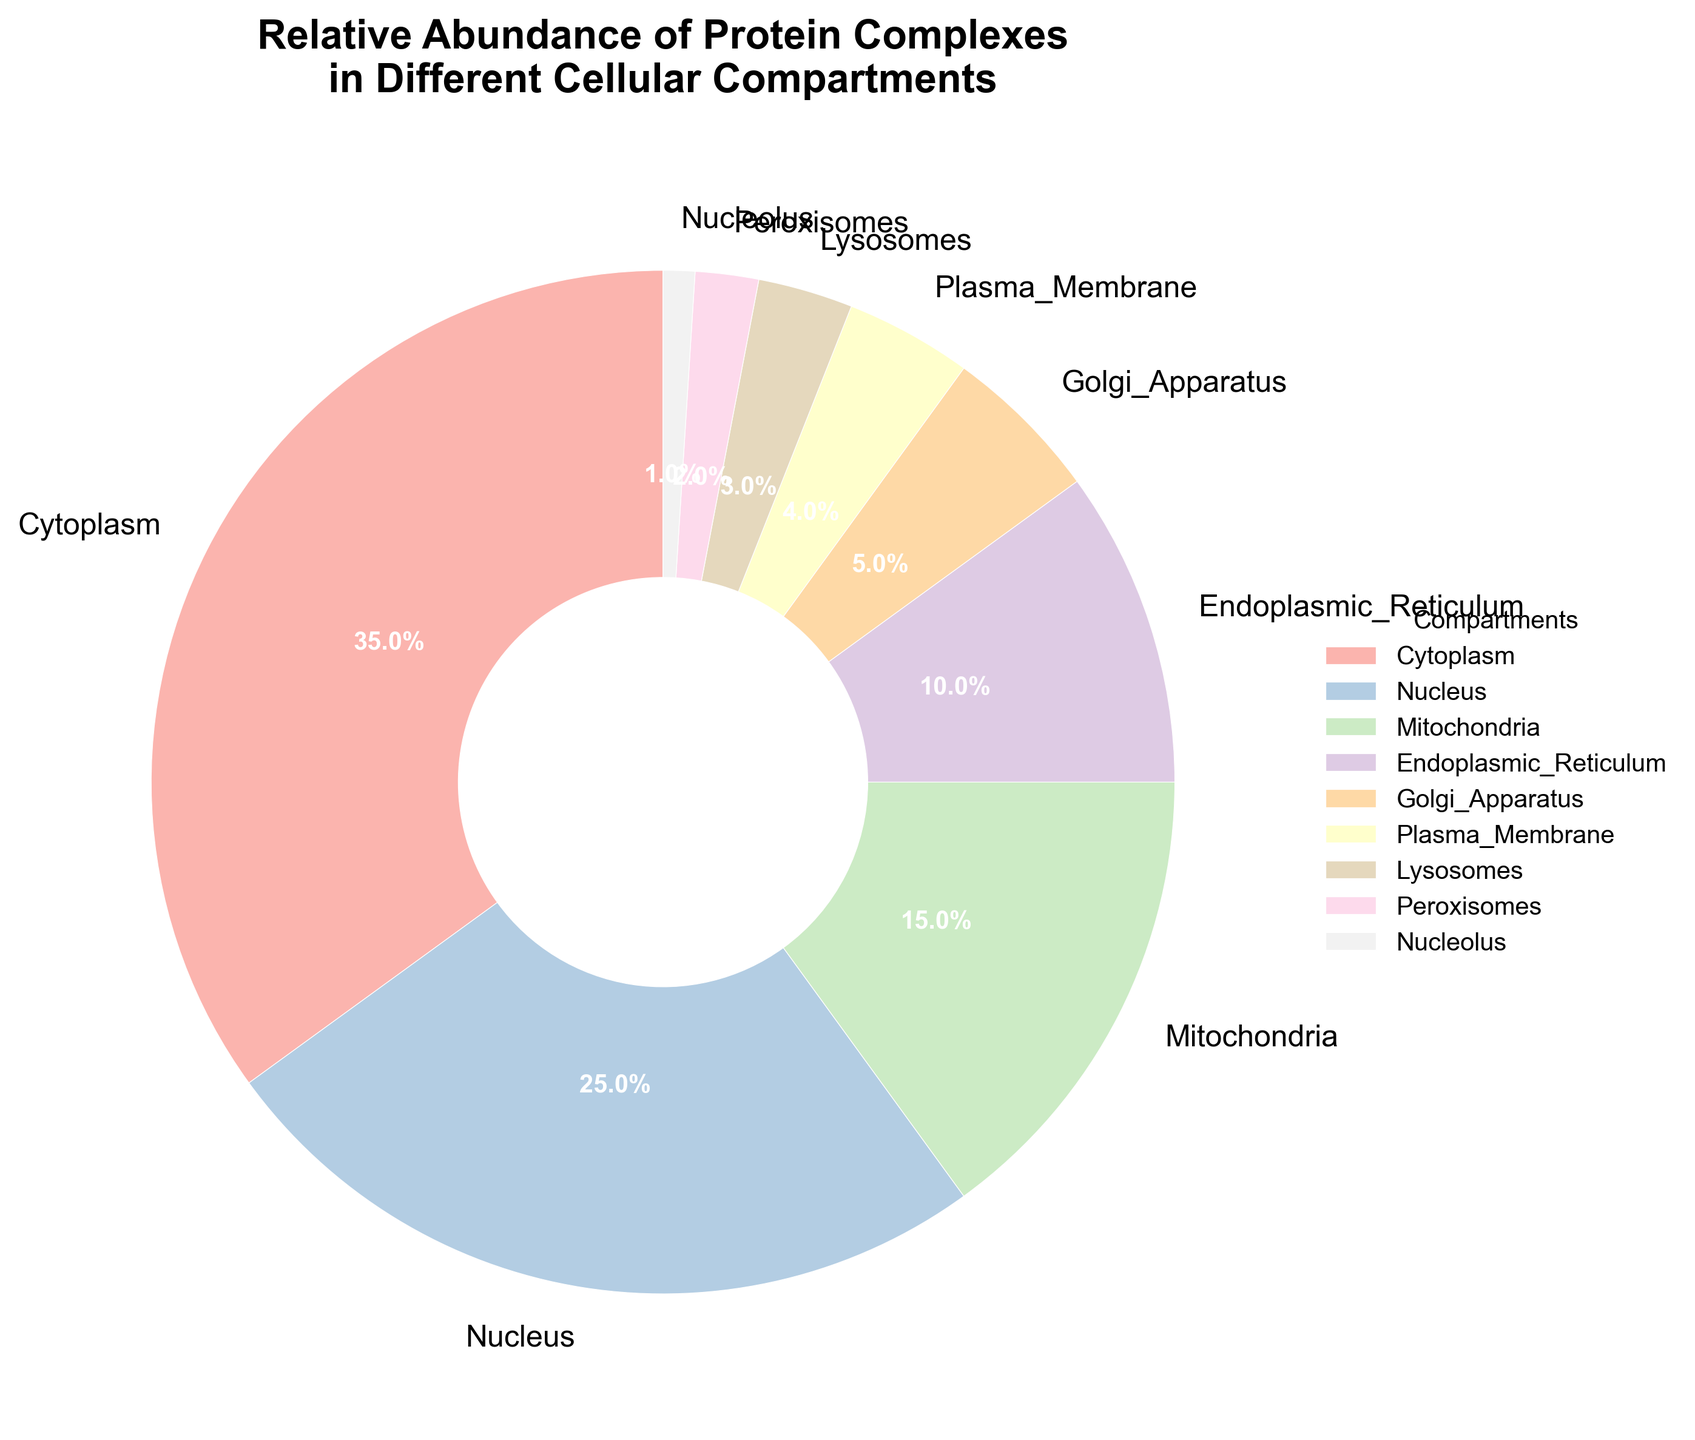Which compartment has the highest relative abundance of protein complexes? By examining the pie chart, the largest wedge represents the Cytoplasm with 35% relative abundance.
Answer: Cytoplasm Which two compartments combined have a relative abundance equal to or surpassing the Cytoplasm? The Cytoplasm has a 35% relative abundance. By adding the Nucleus (25%) and the Mitochondria (15%), we get 25% + 15% = 40%, which surpasses the Cytoplasm’s relative abundance.
Answer: Nucleus and Mitochondria How much more abundant are protein complexes in the Cytoplasm compared to the Endoplasmic Reticulum? The Cytoplasm has a relative abundance of 35%, and the Endoplasmic Reticulum has 10%. The difference is 35% - 10% = 25%.
Answer: 25% Are protein complexes more abundant in the Nucleus or the Plasma Membrane? The pie chart shows the Nucleus with 25% relative abundance and the Plasma Membrane with 4%. Thus, protein complexes are more abundant in the Nucleus.
Answer: Nucleus What is the sum of the relative abundances of compartments with less than 10% relative abundance? Adding the relative abundances of the Golgi Apparatus (5%), Plasma Membrane (4%), Lysosomes (3%), Peroxisomes (2%), and Nucleolus (1%) gives us 5% + 4% + 3% + 2% + 1% = 15%.
Answer: 15% Which compartment has the smallest relative abundance of protein complexes? From the pie chart, the smallest slice represents the Nucleolus with a 1% relative abundance.
Answer: Nucleolus How does the relative abundance of protein complexes in the Mitochondria compare to the Golgi Apparatus? The relative abundance of protein complexes in the Mitochondria (15%) is higher than the Golgi Apparatus (5%).
Answer: Mitochondria What are the top three compartments by relative abundance of protein complexes? By observing the pie chart, the Cytoplasm (35%), Nucleus (25%), and Mitochondria (15%) have the three highest abundances.
Answer: Cytoplasm, Nucleus, and Mitochondria How many compartments have a relative abundance equal to or greater than 10%? By checking each wedge in the pie chart, the Cytoplasm (35%), Nucleus (25%), Mitochondria (15%), and Endoplasmic Reticulum (10%) all meet or exceed 10%. Therefore, there are four compartments.
Answer: 4 Is the combined relative abundance of compartments in the Cytoplasm and Nucleus more than 50%? The Cytoplasm has 35% and the Nucleus has 25%. Adding them together, 35% + 25% = 60%, which is indeed more than 50%.
Answer: Yes 